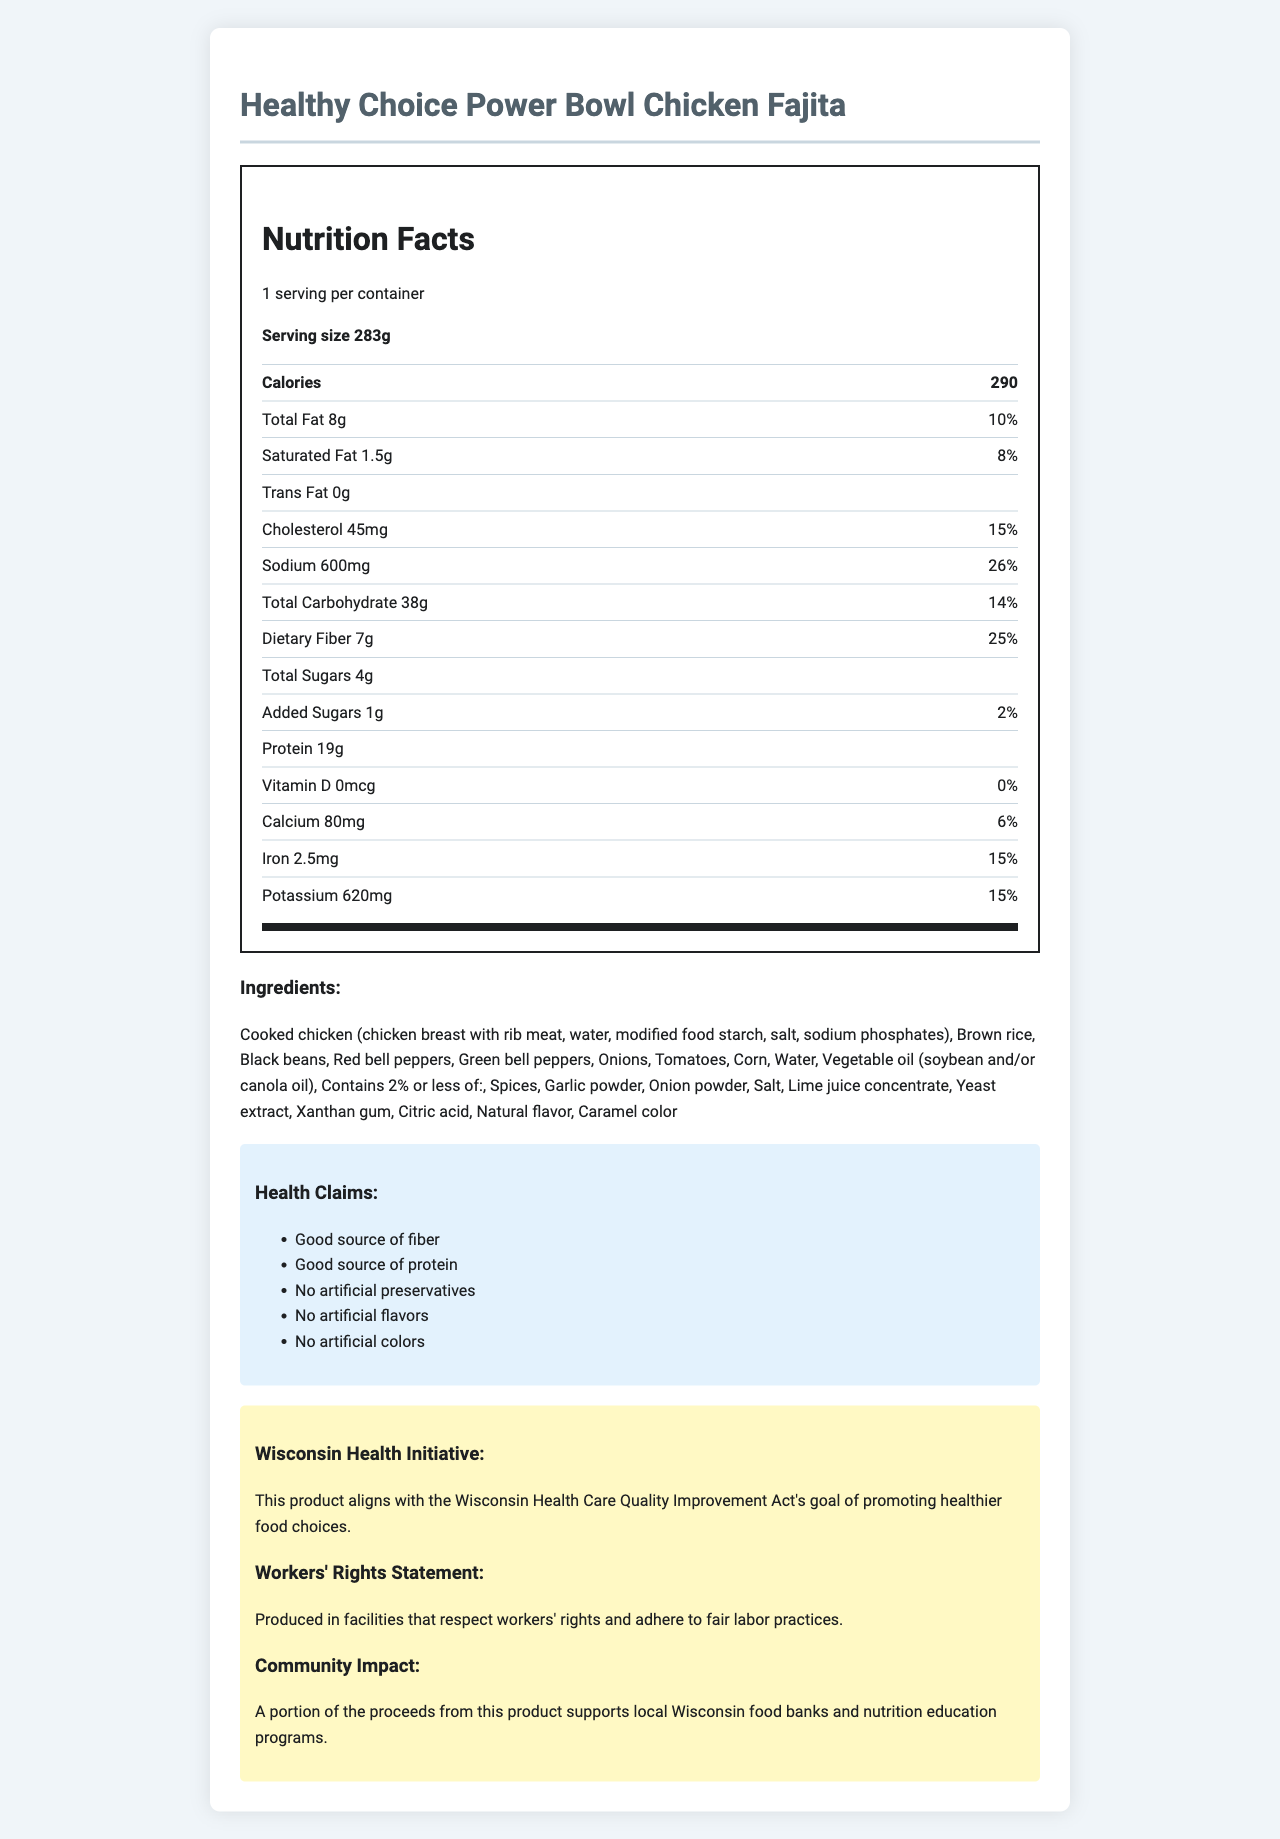who is the target audience for this product? The product includes claims such as "Good source of fiber," "Good source of protein," and "No artificial preservatives, flavors, or colors," making it clear that it targets health-conscious consumers.
Answer: Health-conscious individuals What is the serving size of the meal? The document specifies that the serving size is 283g.
Answer: 283g How many calories are in one serving of this meal? The document states that one serving contains 290 calories.
Answer: 290 Does the product contain any artificial preservatives? The health claims section explicitly states "No artificial preservatives."
Answer: No What percentage of the daily value for sodium does this product contain? The nutrition label lists the sodium content as 600mg, which is 26% of the daily value.
Answer: 26% What allergens are present in this product? The allergens section states that the product contains soy.
Answer: Soy Does the product support any community initiatives? The document mentions that a portion of the proceeds supports local Wisconsin food banks and nutrition education programs.
Answer: Yes What is the amount of dietary fiber in this product? The nutrition facts section shows that the dietary fiber content is 7g.
Answer: 7g What is the protein content of the meal? The nutrition facts section lists the protein content as 19g.
Answer: 19g What are some of the main ingredients in this product? A. Chicken, brown rice, black beans B. Beef, white rice, kidney beans C. Chicken, white rice, black beans D. Turkey, brown rice, lentils The main ingredients listed include "Cooked chicken, Brown rice, and Black beans," which match option A.
Answer: A Which of these is NOT found in the product? 1. Citric acid 2. High fructose corn syrup 3. Yeast extract 4. Xanthan gum High fructose corn syrup is not listed among the ingredients, whereas citric acid, yeast extract, and xanthan gum are.
Answer: 2 Is the product compliant with any local health initiatives? The document states that the product aligns with the Wisconsin Health Care Quality Improvement Act's goal of promoting healthier food choices.
Answer: Yes What kind of oil is used in this product? The ingredients section lists vegetable oil as being either soybean or canola oil.
Answer: Soybean and/or canola oil Does this product contain any added sugars? The nutrition facts list added sugars as 1g.
Answer: Yes Summarize the key claims made about this product. This summary is based on the provided health claims, functional ingredients, community initiatives, and workers' rights statements detailed in the document.
Answer: The product is a healthy, microwaveable meal that contains no artificial preservatives, flavors, or colors, is a good source of fiber and protein, supports local community initiatives, and adheres to fair labor practices. Are the manufacturing facilities of this product compliant with workers' rights standards? The document states that the product is produced in facilities that respect workers' rights and adhere to fair labor practices.
Answer: Yes What vitamins or minerals are particularly highlighted in the nutrition facts? The nutrition facts highlight calcium (80mg), iron (2.5mg), and potassium (620mg) with their corresponding daily values.
Answer: Calcium, Iron, Potassium What is the daily value percentage for total carbohydrates? The nutrition facts state that the total carbohydrate content is 38g, which is 14% of the daily value.
Answer: 14% What food element's daily value percentage is highest in this product? Among the listed daily values, sodium has the highest percentage at 26%.
Answer: Sodium How many grams of trans fat are in one serving? The nutrition facts label indicates that there are 0 grams of trans fat.
Answer: 0g What is the purpose of caramel color in the ingredients? The document lists caramel color as an ingredient, but it doesn't provide its purpose or function.
Answer: Not enough information How does this product align with the Wisconsin Health Care Quality Improvement Act? The document states that the product aligns with the Wisconsin Health Care Quality Improvement Act's goal of promoting healthier food choices.
Answer: By promoting healthier food choices In what ways does this product support the local community in Wisconsin? The document mentions that a portion of the proceeds from the product supports local Wisconsin food banks and nutrition education programs.
Answer: Proceeds support local food banks and nutrition education programs 